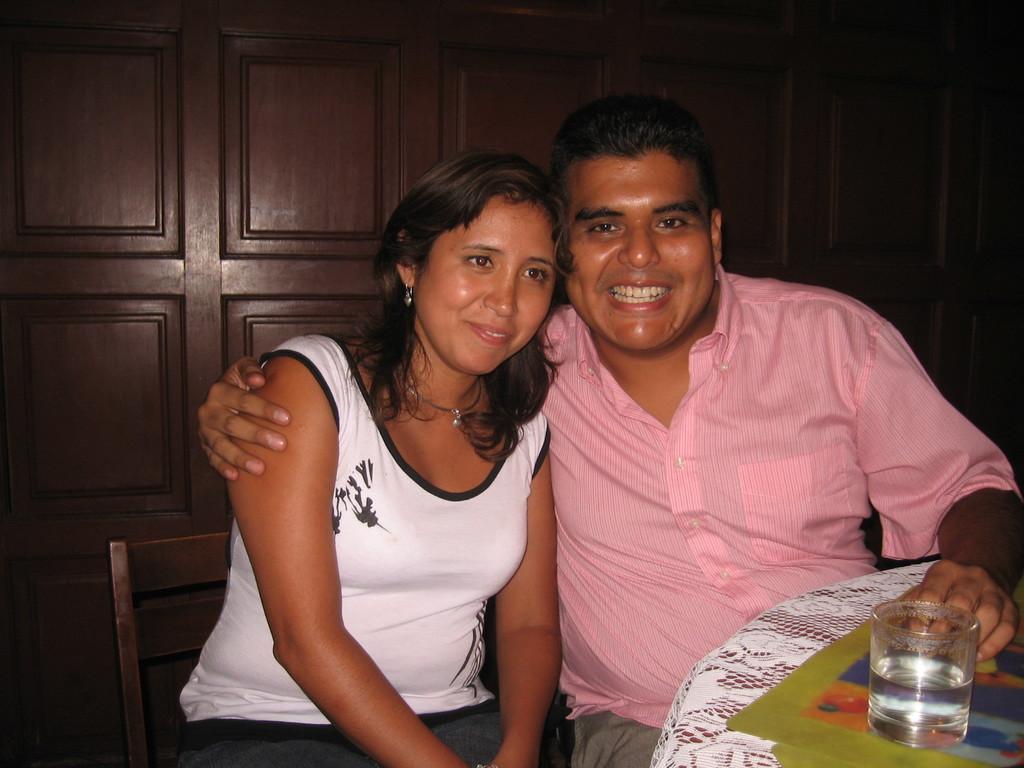Can you describe this image briefly? In the center of the image there is a lady and a man sitting on the chairs. There is a table to the right side of the image. There is a glass on the table. In the background of the image there is a wooden wall. 